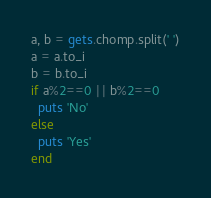Convert code to text. <code><loc_0><loc_0><loc_500><loc_500><_Ruby_>a, b = gets.chomp.split(' ')
a = a.to_i
b = b.to_i
if a%2==0 || b%2==0
  puts 'No'
else
  puts 'Yes'
end
</code> 